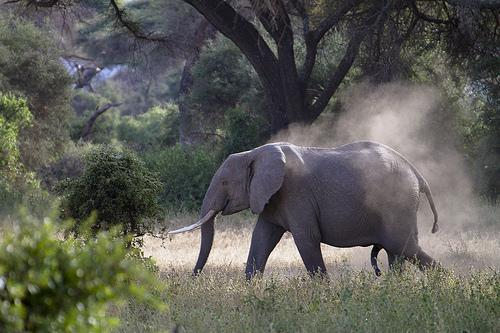Relate the image to an engaging, descriptive story. In the wild, a majestic grey elephant with large ears wanders through lush green grass, raising a cloud of dust as it strides with its four strong legs. Identify the number of visible small green bushes. There are at least one small green bush on the left side of the image. What emotions can you perceive from the picture? Is it peaceful, chaotic, or something else? The image evokes a sense of peacefulness and calm, as the elephant walks through the natural landscape. How many elephants total can you find in this image, and what are they up to? There is only one elephant, and it is walking through a field of grass. Perform a complex analysis on the interaction between the elephant and its surroundings. The elephant appears to be in harmony with its surroundings, as it quietly walks through the grass, raising a small cloud of dust, being at one with nature. Count the number of ears, tusks, and legs on the elephant in the image. The elephant has two ears, two tusks, and four legs. What is the environment like around the elephant in the image? The elephant is surrounded by green and brown grass, small bushes, and a large tree under a blue sky. Evaluate the overall aesthetics of the image - is it well-balanced, appealing and well-lit? The image is well-balanced, with the elephant in the center, surrounded by an appealing natural landscape and trees that have suitable lighting, creating visual harmony. Mention the primary object seen in the image and describe its activity. A grey elephant is walking through a field of tall grass scattering dirt in the air. List three features of the elephant in the image. Large grey ears, white tusks, and a narrow tail. Identify what is the emotion of the elephant and which facial feature can you see in the image. Cannot identify the emotion, small black left eye is visible. What is one possible activity that the elephant is performing? Walking through a field of grass. What type of scene is depicted in this image? An elephant walking in a field of tall grass with trees in the background. Is there any evidence of the elephant stirring up dirt in the air? Yes, there is dirt scattered in the air around the elephant. What color is the elephant in the image? Grey. How many total legs of the elephant are described? Four gray legs. Choose which part of the elephant is larger: (a) front leg (b) tusk. (a) front leg. Is there a tree in the image? If yes, where is it located? Yes, there is a large tree behind the elephant. Indicate the presence of any sky or clouds in the image. Blue sky seen through trees. Describe the main object in the image. A large grey elephant in the wild. What activity is the elephant performing in the field? Walking in a field of tall grass. What kind of plant is in the foreground of the image? Bush with green leaves. Describe the appearance of the elephant's ear. Big gray left ear. Describe the environment of the image. Field of green and brown grass, blue sky seen through trees, and green leaves in the foreground. How many front legs of the elephant are mentioned?  Two. Identify if there are any bushes in the image. Yes, there are small green bushes in the left. From the given options, choose the predominant color of the grass in the image: (a) blue (b) green (c) brown (d) red. (b) green. Is the elephant's tail visible? If so, describe its appearance. Yes, it is a little gray narrow tail. Name one distinct feature of the elephant. Large white tusk. 